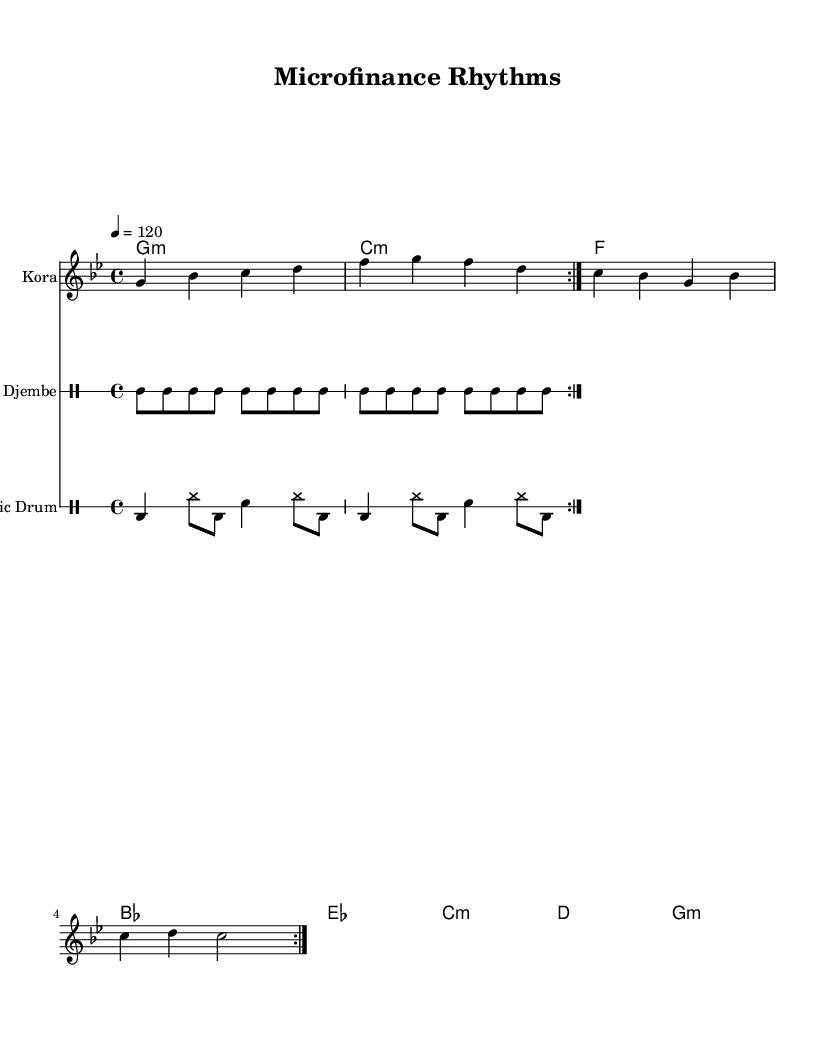What is the key signature of this music? The key signature is G minor, indicated by one flat (B♭). This can be determined by looking at the key signature at the beginning of the staff where it shows one flat.
Answer: G minor What is the time signature of this music? The time signature is 4/4, which is shown at the start of the music. It indicates that there are four beats per measure and the quarter note gets one beat.
Answer: 4/4 What is the tempo marking for this piece? The tempo marking shows that the piece should be played at a speed of 120 beats per minute, indicated by "4 = 120" at the beginning. This specifies how fast the music is to be played.
Answer: 120 How many measures are in the djembe part? The djembe part contains 8 measures, which can be counted by identifying the individual repeating sections in the djembe notation. Each repeat indicates two measures, and there are four sets of repeats.
Answer: 8 What instruments are used in this composition? The composition features three instruments: the kora, djembe, and electronic drums. The names of the instruments are labeled above their respective staves in the sheet music.
Answer: Kora, Djembe, Electronic Drums What type of rhythm pattern is present in the electronic drum part? The electronic drum part features a combination of bass drum, hi-hat, and snare drum patterns. This can be observed by analyzing the specific drum notation, which alternates between these elements.
Answer: Bass drum, Hi-hat, Snare What musical role does the synthesizer serve in this piece? The synthesizer serves as the harmonic support providing chords throughout the piece. This is evident from the chord symbols that are listed above its staff, which accompany the melody from the kora.
Answer: Harmonic support 